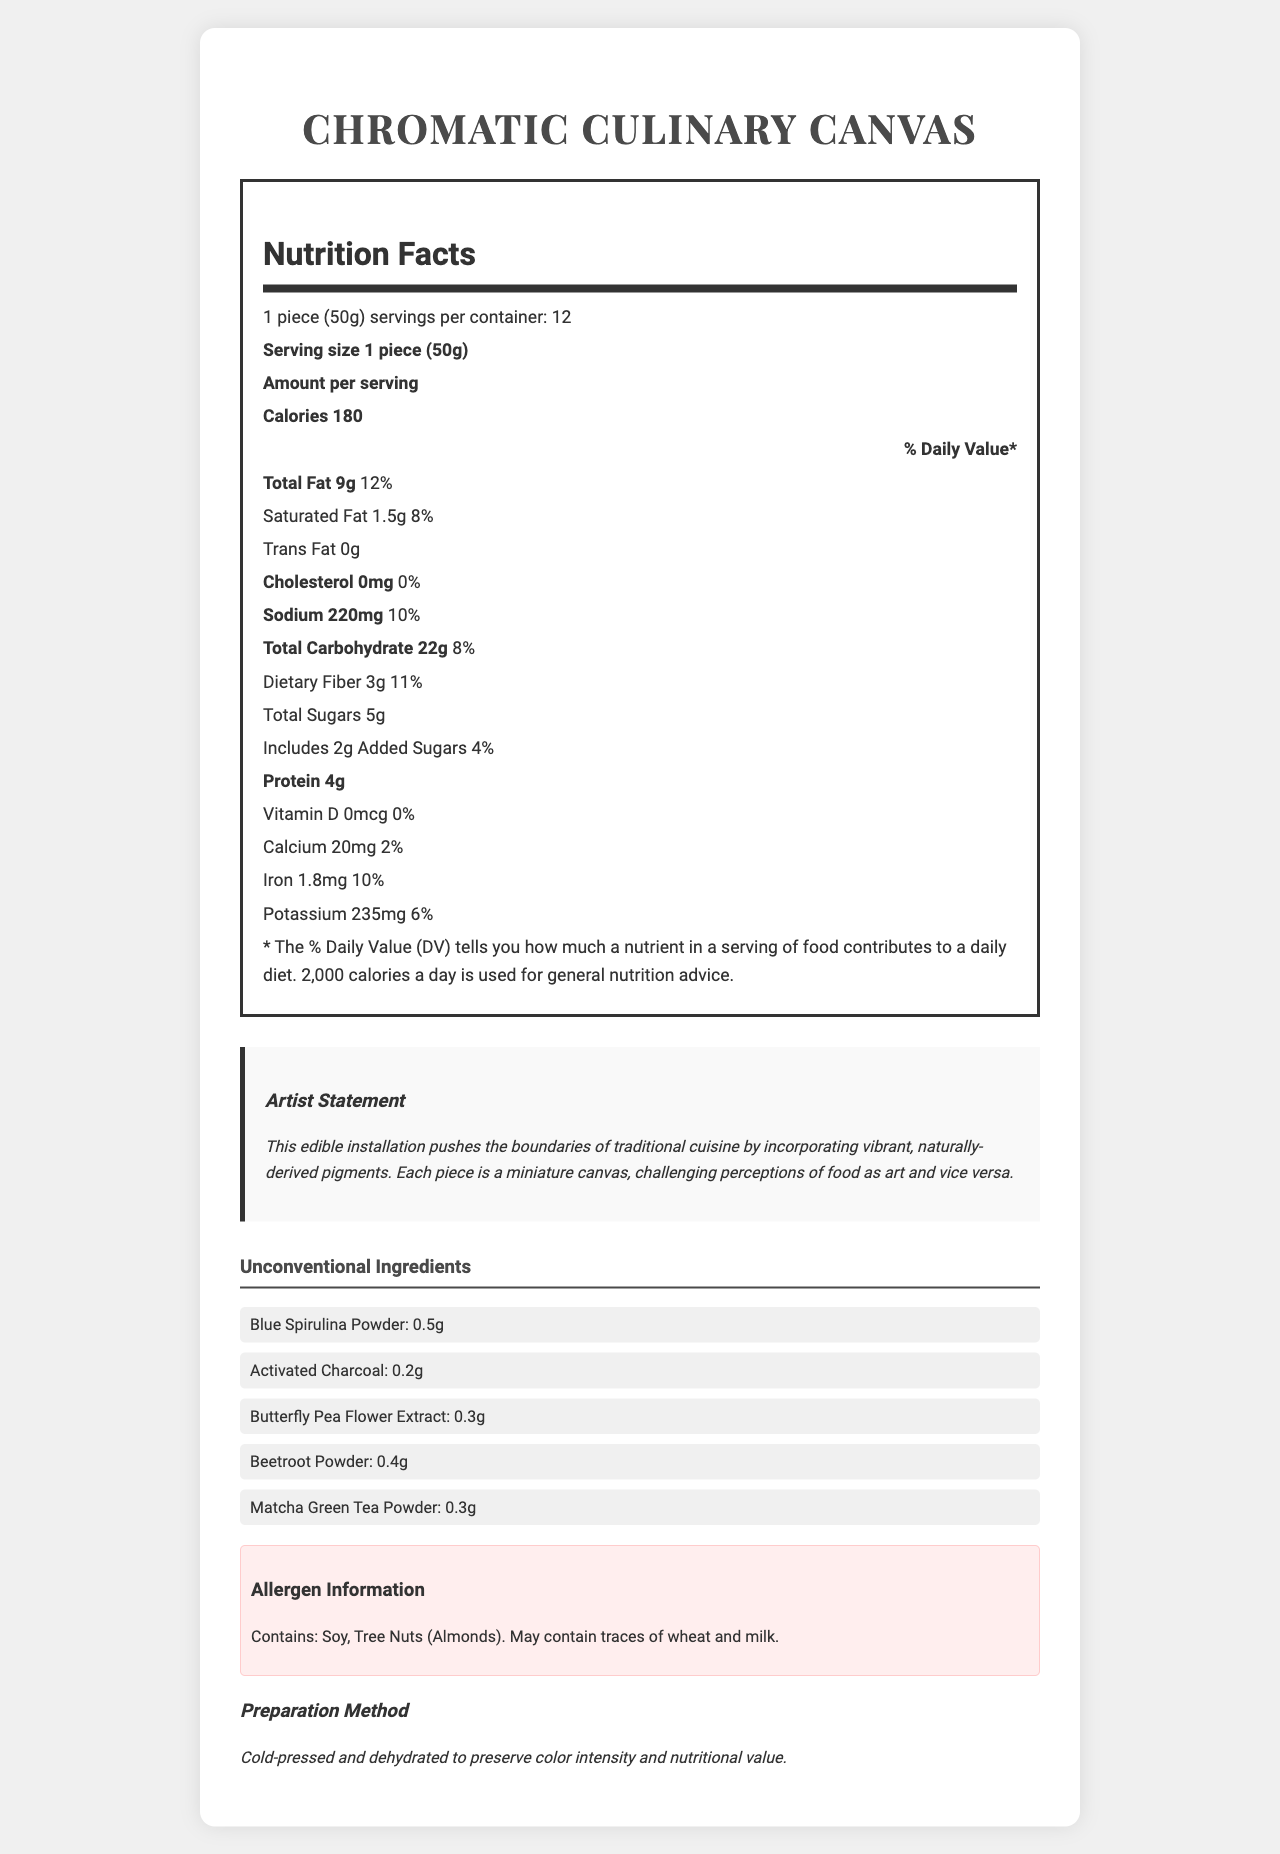what is the serving size of "Chromatic Culinary Canvas"? The document specifies that the serving size is 1 piece which weighs 50 grams.
Answer: 1 piece (50g) how many calories are in one serving? The document states that each serving contains 180 calories.
Answer: 180 how much sodium does one piece contain? The document lists the sodium content as 220 mg.
Answer: 220 mg what is the total amount of fat per serving? The document indicates that the total fat per serving is 9 grams.
Answer: 9 g which unconventional ingredient is used in the greatest amount? Blue Spirulina Powder is listed first with an amount of 0.5g, which is the highest among the unconventional ingredients.
Answer: Blue Spirulina Powder how much dietary fiber is in one serving? The document states that there are 3 grams of dietary fiber per serving.
Answer: 3 g how many servings are in the entire container? The document indicates that there are 12 servings per container.
Answer: 12 which of the following allergens are contained in the product? A. Wheat B. Soy C. Dairy D. Peanuts The document specifies that the product contains Soy, and it also may contain traces of wheat and milk, but Soy is explicitly listed.
Answer: B. Soy what daily value percentage of iron does one serving provide? A. 2% B. 6% C. 10% D. 12% The document lists the daily value percentage of iron per serving as 10%.
Answer: C. 10% is the product high in protein? With 4 grams of protein per serving, it is not particularly high compared to other food products.
Answer: No summarize the main content of the document. The document details the nutritional facts, unique ingredients, allergen warnings, and preparation methods, along with an artistic statement on the concept.
Answer: The document provides a comprehensive breakdown of the nutritional information, unconventional ingredients, allergen info, and artist's statement for the "Chromatic Culinary Canvas," an innovative edible art piece. what is the method of preparation for this product? The document indicates the preparation method is cold-pressed and dehydrated to preserve both color intensity and nutritional value.
Answer: Cold-pressed and dehydrated to preserve color intensity and nutritional value. what amount of butterfly pea flower extract is in one piece? The document lists 0.3g as the amount of butterfly pea flower extract in one piece.
Answer: 0.3g what percentage of daily value is the saturated fat per serving? The document states that the saturated fat per serving is 1.5 grams, which is 8% of the daily value.
Answer: 8% what is the artist's statement about the product? The document contains an artist statement explaining the conceptual and visual elements of the product.
Answer: The edible installation pushes the boundaries of traditional cuisine by incorporating vibrant, naturally-derived pigments. Each piece is a miniature canvas, challenging perceptions of food as art and vice versa. how does the product compare in cholesterol content to typical high-cholesterol foods? The document specifies that each serving has 0 mg of cholesterol, making it a cholesterol-free item.
Answer: The product contains 0 mg of cholesterol, which is significantly lower compared to high-cholesterol foods. what colors might you expect from the ingredients used? The ingredients list includes naturally pigmented additives that likely give the product vibrant colors.
Answer: Various colors derived from blue spirulina, activated charcoal (black), butterfly pea flower extract (blue/purple), beetroot powder (red/purple), and matcha green tea powder (green). can we determine the expiry date from the document? The document does not provide any information about the expiry date.
Answer: Not enough information what is one unique selling point mentioned in the artist's statement? The artist's statement highlights the use of vibrant, naturally-derived pigments as a primary factor that sets the product apart.
Answer: The use of vibrant, naturally-derived pigments. how many grams of added sugars are there in one serving? The document lists the amount of added sugars in one serving as 2 grams.
Answer: 2 g 